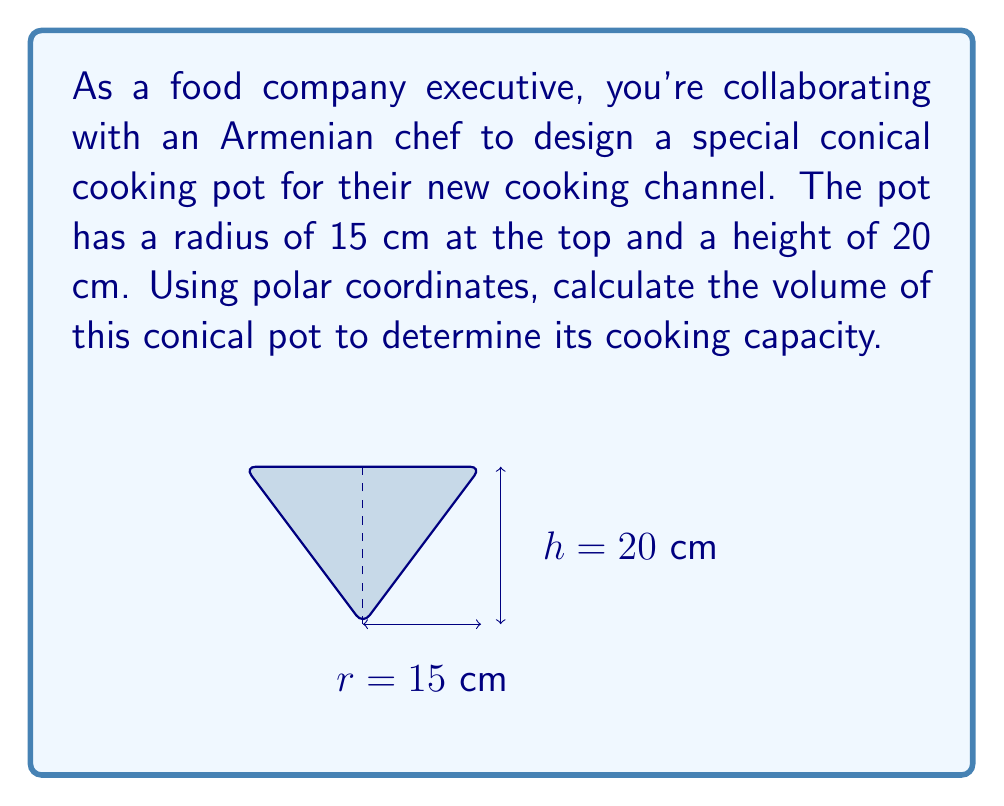Help me with this question. To calculate the volume of a conical pot using polar coordinates, we'll follow these steps:

1) In polar coordinates, the volume of a solid of revolution is given by:

   $$V = \frac{1}{3}\int_0^h \pi r^2(z) dz$$

   where $r(z)$ is the radius at height $z$.

2) For a cone, the radius at any height $z$ is proportional to the distance from the top:

   $$r(z) = \frac{R}{h}(h-z)$$

   where $R$ is the radius at the base and $h$ is the height.

3) Substituting our values ($R=15$ cm, $h=20$ cm):

   $$r(z) = \frac{15}{20}(20-z) = \frac{3}{4}(20-z)$$

4) Now we can set up our integral:

   $$V = \frac{1}{3}\int_0^{20} \pi [\frac{3}{4}(20-z)]^2 dz$$

5) Simplify the integrand:

   $$V = \frac{1}{3}\pi (\frac{3}{4})^2 \int_0^{20} (20-z)^2 dz$$

6) Evaluate the integral:

   $$V = \frac{1}{3}\pi (\frac{3}{4})^2 [\frac{-(20-z)^3}{3}]_0^{20}$$

   $$V = \frac{1}{3}\pi (\frac{3}{4})^2 [\frac{-0^3}{3} - \frac{-20^3}{3}]$$

   $$V = \frac{1}{3}\pi (\frac{3}{4})^2 [\frac{8000}{3}]$$

7) Simplify:

   $$V = \pi (\frac{3}{4})^2 \frac{8000}{9} = \frac{3000\pi}{4} \approx 2356.19 \text{ cm}^3$$
Answer: $\frac{3000\pi}{4} \text{ cm}^3$ or approximately 2356.19 $\text{cm}^3$ 